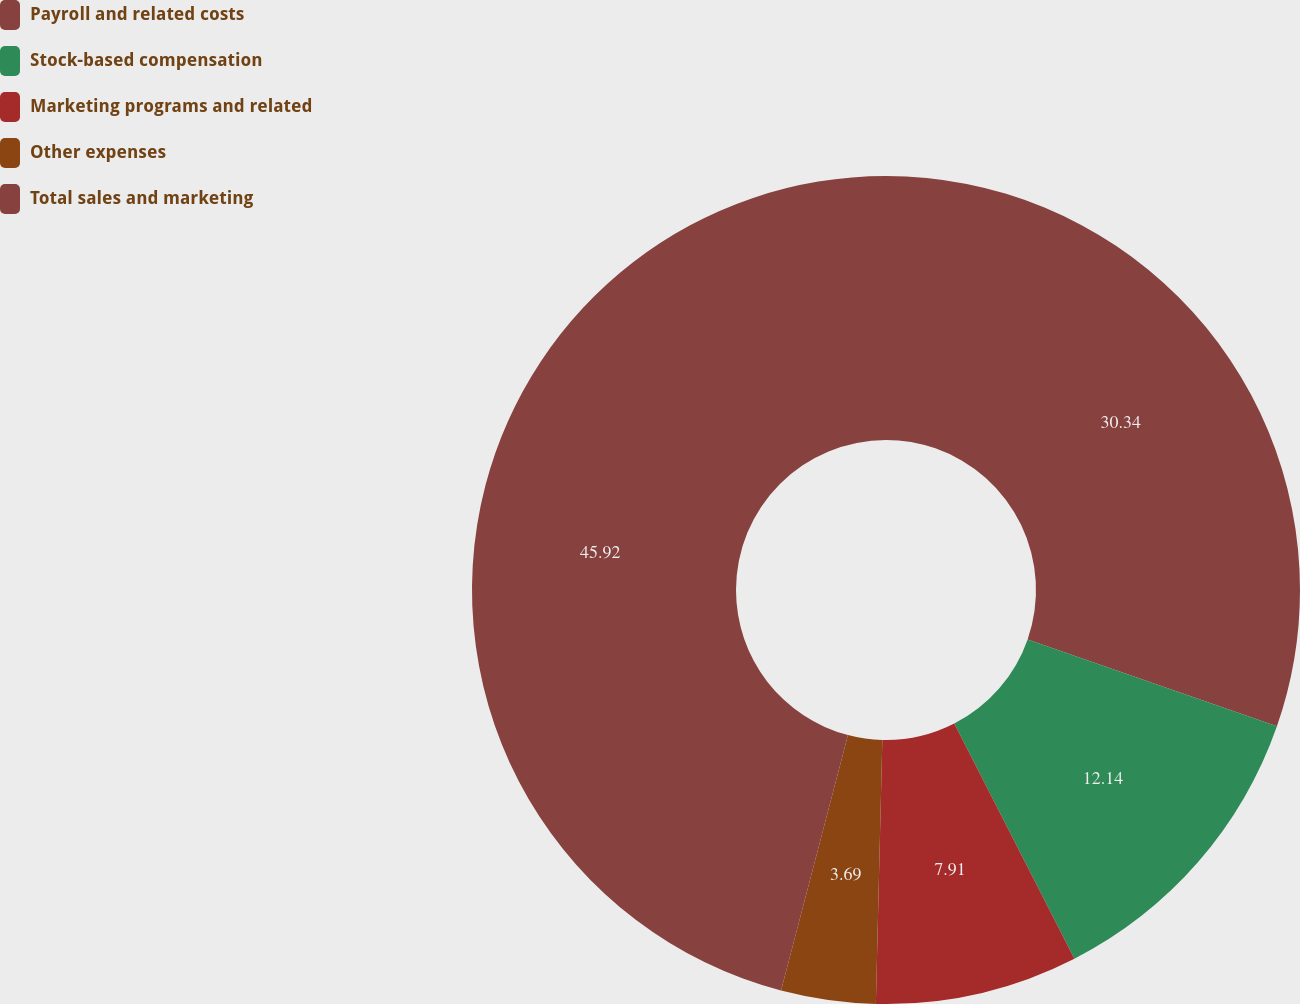Convert chart to OTSL. <chart><loc_0><loc_0><loc_500><loc_500><pie_chart><fcel>Payroll and related costs<fcel>Stock-based compensation<fcel>Marketing programs and related<fcel>Other expenses<fcel>Total sales and marketing<nl><fcel>30.34%<fcel>12.14%<fcel>7.91%<fcel>3.69%<fcel>45.92%<nl></chart> 